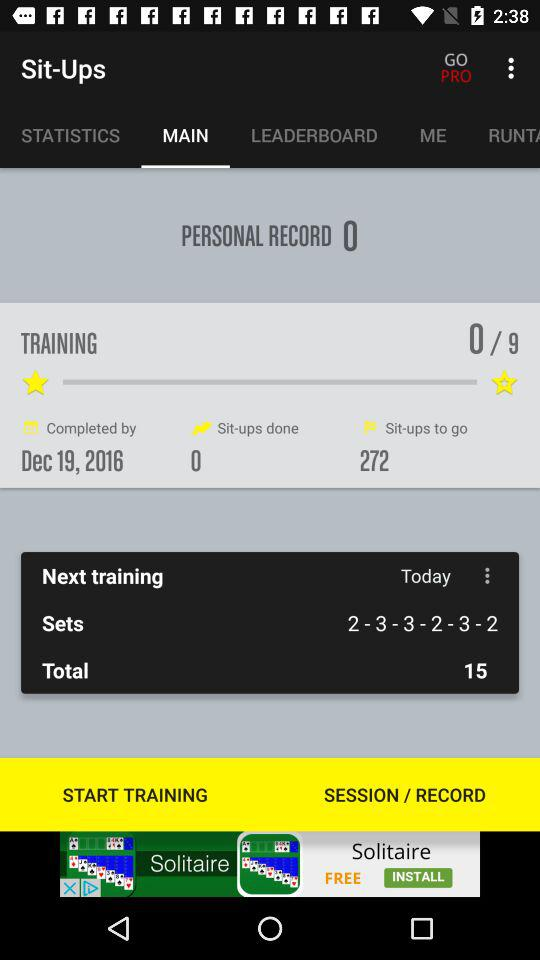How many sit-ups are done? There are 0 sit-ups done. 